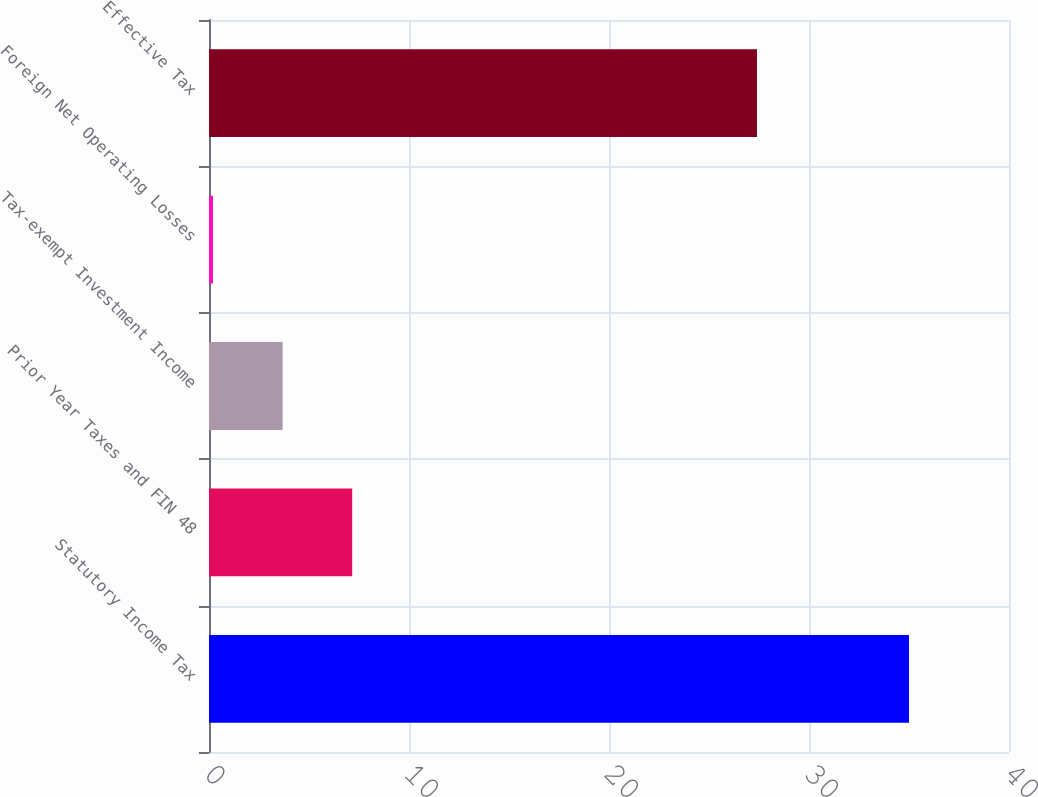<chart> <loc_0><loc_0><loc_500><loc_500><bar_chart><fcel>Statutory Income Tax<fcel>Prior Year Taxes and FIN 48<fcel>Tax-exempt Investment Income<fcel>Foreign Net Operating Losses<fcel>Effective Tax<nl><fcel>35<fcel>7.16<fcel>3.68<fcel>0.2<fcel>27.4<nl></chart> 